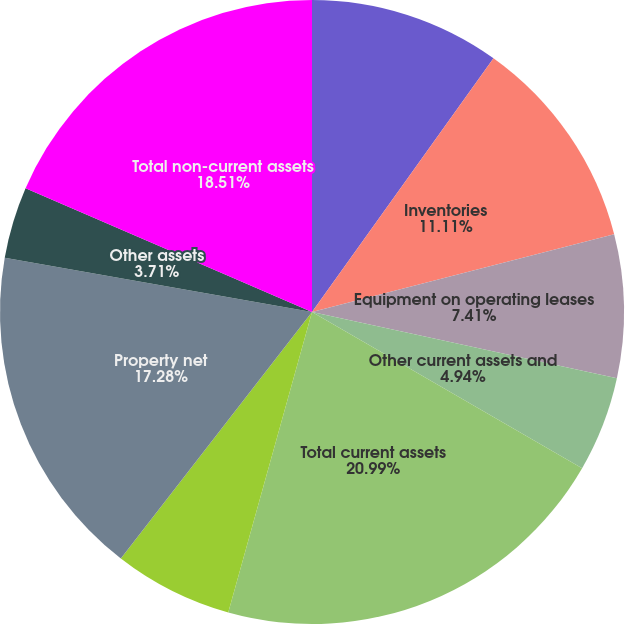<chart> <loc_0><loc_0><loc_500><loc_500><pie_chart><fcel>Accounts and notes receivable<fcel>Inventories<fcel>Equipment on operating leases<fcel>Other current assets and<fcel>Total current assets<fcel>Equity in net assets of non<fcel>Property net<fcel>Deferred income taxes<fcel>Other assets<fcel>Total non-current assets<nl><fcel>9.88%<fcel>11.11%<fcel>7.41%<fcel>4.94%<fcel>20.98%<fcel>6.17%<fcel>17.28%<fcel>0.0%<fcel>3.71%<fcel>18.51%<nl></chart> 